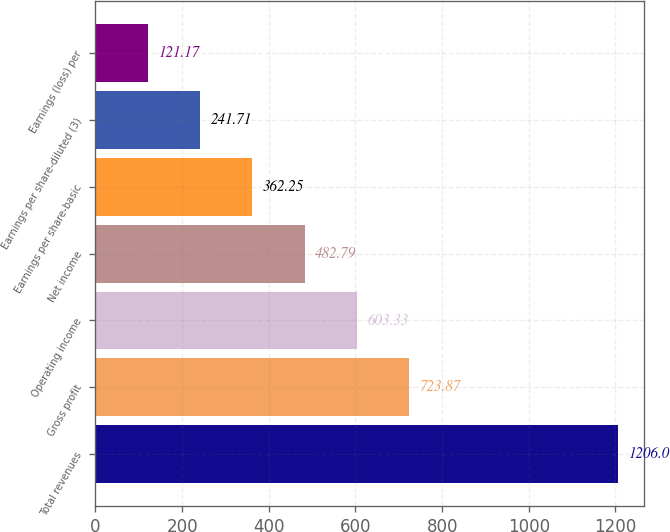Convert chart. <chart><loc_0><loc_0><loc_500><loc_500><bar_chart><fcel>Total revenues<fcel>Gross profit<fcel>Operating income<fcel>Net income<fcel>Earnings per share-basic<fcel>Earnings per share-diluted (3)<fcel>Earnings (loss) per<nl><fcel>1206<fcel>723.87<fcel>603.33<fcel>482.79<fcel>362.25<fcel>241.71<fcel>121.17<nl></chart> 